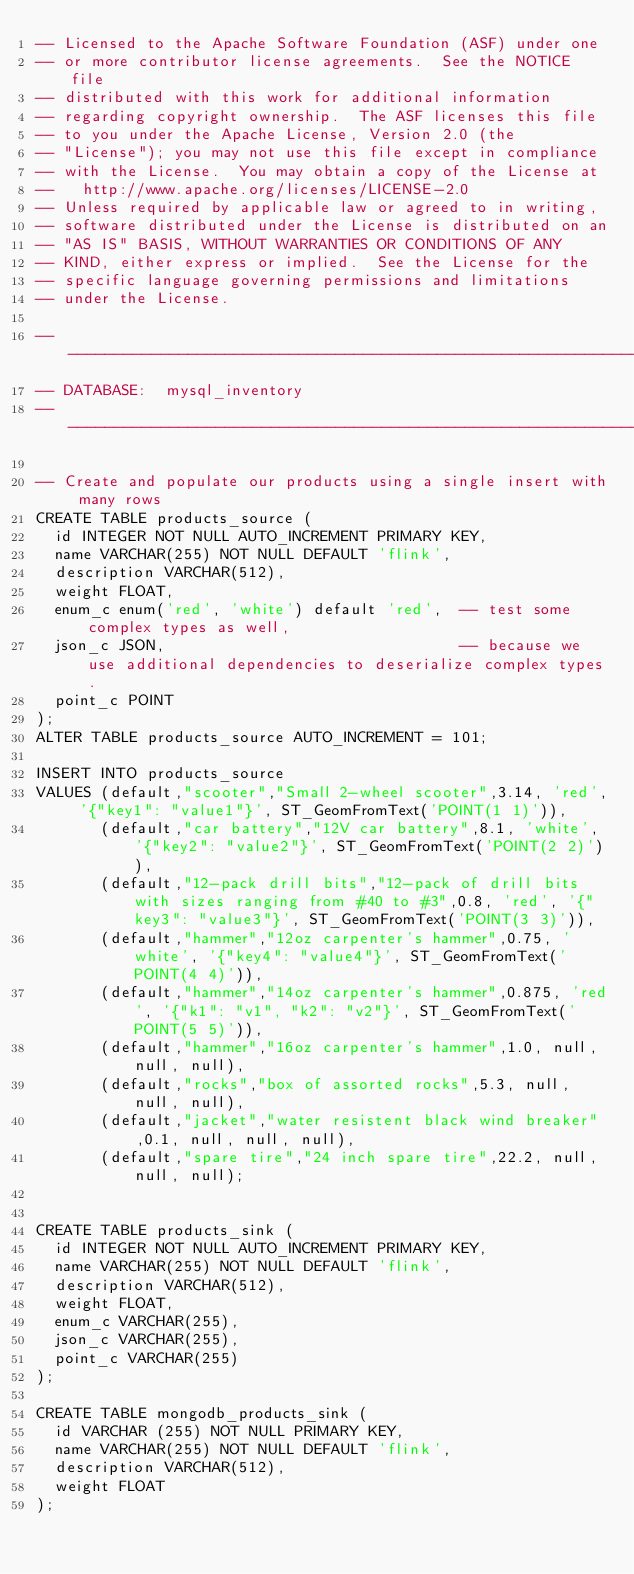Convert code to text. <code><loc_0><loc_0><loc_500><loc_500><_SQL_>-- Licensed to the Apache Software Foundation (ASF) under one
-- or more contributor license agreements.  See the NOTICE file
-- distributed with this work for additional information
-- regarding copyright ownership.  The ASF licenses this file
-- to you under the Apache License, Version 2.0 (the
-- "License"); you may not use this file except in compliance
-- with the License.  You may obtain a copy of the License at
--   http://www.apache.org/licenses/LICENSE-2.0
-- Unless required by applicable law or agreed to in writing,
-- software distributed under the License is distributed on an
-- "AS IS" BASIS, WITHOUT WARRANTIES OR CONDITIONS OF ANY
-- KIND, either express or implied.  See the License for the
-- specific language governing permissions and limitations
-- under the License.

-- ----------------------------------------------------------------------------------------------------------------
-- DATABASE:  mysql_inventory
-- ----------------------------------------------------------------------------------------------------------------

-- Create and populate our products using a single insert with many rows
CREATE TABLE products_source (
  id INTEGER NOT NULL AUTO_INCREMENT PRIMARY KEY,
  name VARCHAR(255) NOT NULL DEFAULT 'flink',
  description VARCHAR(512),
  weight FLOAT,
  enum_c enum('red', 'white') default 'red',  -- test some complex types as well,
  json_c JSON,                                -- because we use additional dependencies to deserialize complex types.
  point_c POINT
);
ALTER TABLE products_source AUTO_INCREMENT = 101;

INSERT INTO products_source
VALUES (default,"scooter","Small 2-wheel scooter",3.14, 'red', '{"key1": "value1"}', ST_GeomFromText('POINT(1 1)')),
       (default,"car battery","12V car battery",8.1, 'white', '{"key2": "value2"}', ST_GeomFromText('POINT(2 2)')),
       (default,"12-pack drill bits","12-pack of drill bits with sizes ranging from #40 to #3",0.8, 'red', '{"key3": "value3"}', ST_GeomFromText('POINT(3 3)')),
       (default,"hammer","12oz carpenter's hammer",0.75, 'white', '{"key4": "value4"}', ST_GeomFromText('POINT(4 4)')),
       (default,"hammer","14oz carpenter's hammer",0.875, 'red', '{"k1": "v1", "k2": "v2"}', ST_GeomFromText('POINT(5 5)')),
       (default,"hammer","16oz carpenter's hammer",1.0, null, null, null),
       (default,"rocks","box of assorted rocks",5.3, null, null, null),
       (default,"jacket","water resistent black wind breaker",0.1, null, null, null),
       (default,"spare tire","24 inch spare tire",22.2, null, null, null);


CREATE TABLE products_sink (
  id INTEGER NOT NULL AUTO_INCREMENT PRIMARY KEY,
  name VARCHAR(255) NOT NULL DEFAULT 'flink',
  description VARCHAR(512),
  weight FLOAT,
  enum_c VARCHAR(255),
  json_c VARCHAR(255),
  point_c VARCHAR(255)
);

CREATE TABLE mongodb_products_sink (
  id VARCHAR (255) NOT NULL PRIMARY KEY,
  name VARCHAR(255) NOT NULL DEFAULT 'flink',
  description VARCHAR(512),
  weight FLOAT
);</code> 